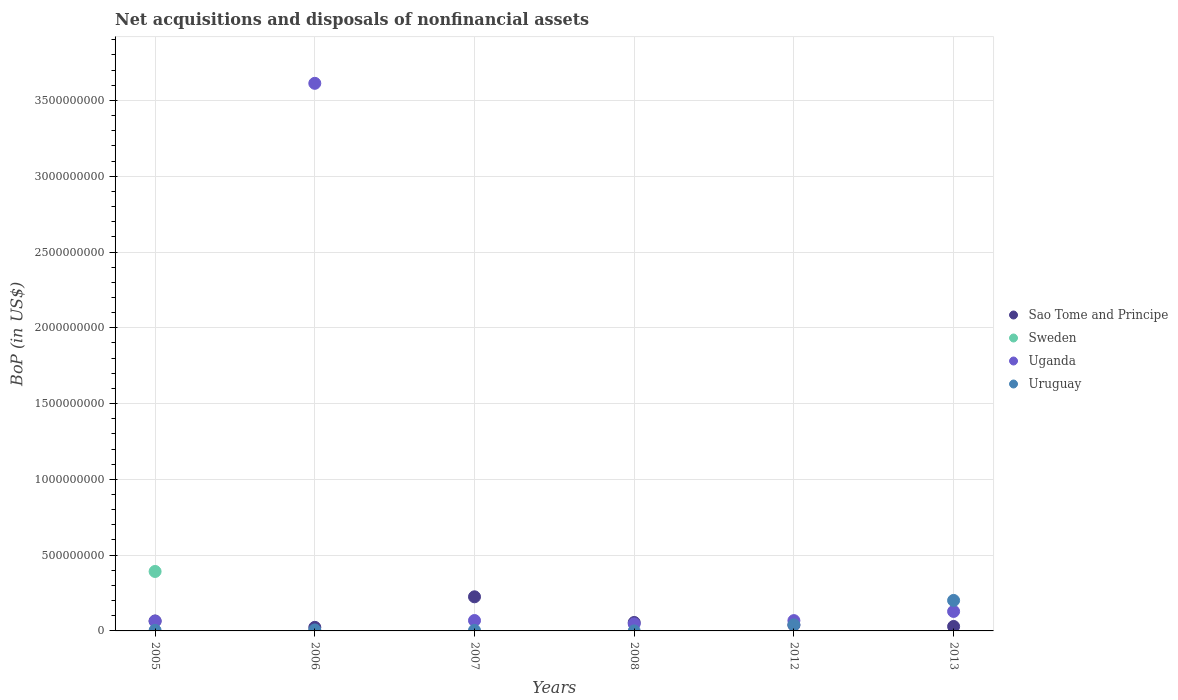How many different coloured dotlines are there?
Keep it short and to the point. 4. What is the Balance of Payments in Sao Tome and Principe in 2007?
Keep it short and to the point. 2.25e+08. Across all years, what is the maximum Balance of Payments in Sao Tome and Principe?
Your answer should be compact. 2.25e+08. Across all years, what is the minimum Balance of Payments in Uruguay?
Your response must be concise. 2.14e+05. What is the total Balance of Payments in Uruguay in the graph?
Give a very brief answer. 2.55e+08. What is the difference between the Balance of Payments in Uruguay in 2008 and that in 2013?
Keep it short and to the point. -2.01e+08. What is the difference between the Balance of Payments in Sao Tome and Principe in 2013 and the Balance of Payments in Uruguay in 2005?
Make the answer very short. 2.56e+07. What is the average Balance of Payments in Sao Tome and Principe per year?
Your response must be concise. 7.30e+07. In the year 2005, what is the difference between the Balance of Payments in Uruguay and Balance of Payments in Sweden?
Provide a succinct answer. -3.88e+08. What is the ratio of the Balance of Payments in Uruguay in 2008 to that in 2012?
Your answer should be compact. 0.01. Is the Balance of Payments in Uganda in 2006 less than that in 2012?
Your answer should be compact. No. What is the difference between the highest and the second highest Balance of Payments in Uruguay?
Ensure brevity in your answer.  1.61e+08. What is the difference between the highest and the lowest Balance of Payments in Sao Tome and Principe?
Your response must be concise. 2.02e+08. In how many years, is the Balance of Payments in Uruguay greater than the average Balance of Payments in Uruguay taken over all years?
Your response must be concise. 1. Is the sum of the Balance of Payments in Sao Tome and Principe in 2006 and 2012 greater than the maximum Balance of Payments in Uganda across all years?
Offer a terse response. No. Is it the case that in every year, the sum of the Balance of Payments in Uganda and Balance of Payments in Sao Tome and Principe  is greater than the Balance of Payments in Sweden?
Make the answer very short. No. Does the Balance of Payments in Uganda monotonically increase over the years?
Ensure brevity in your answer.  No. Is the Balance of Payments in Sweden strictly less than the Balance of Payments in Uganda over the years?
Offer a very short reply. No. What is the difference between two consecutive major ticks on the Y-axis?
Give a very brief answer. 5.00e+08. Does the graph contain grids?
Ensure brevity in your answer.  Yes. Where does the legend appear in the graph?
Give a very brief answer. Center right. How are the legend labels stacked?
Your response must be concise. Vertical. What is the title of the graph?
Your response must be concise. Net acquisitions and disposals of nonfinancial assets. What is the label or title of the Y-axis?
Keep it short and to the point. BoP (in US$). What is the BoP (in US$) in Sao Tome and Principe in 2005?
Provide a short and direct response. 6.56e+07. What is the BoP (in US$) in Sweden in 2005?
Ensure brevity in your answer.  3.92e+08. What is the BoP (in US$) in Uganda in 2005?
Offer a terse response. 6.43e+07. What is the BoP (in US$) of Uruguay in 2005?
Offer a terse response. 3.83e+06. What is the BoP (in US$) in Sao Tome and Principe in 2006?
Your answer should be compact. 2.35e+07. What is the BoP (in US$) in Uganda in 2006?
Provide a short and direct response. 3.61e+09. What is the BoP (in US$) of Uruguay in 2006?
Provide a short and direct response. 6.51e+06. What is the BoP (in US$) in Sao Tome and Principe in 2007?
Make the answer very short. 2.25e+08. What is the BoP (in US$) in Sweden in 2007?
Your answer should be compact. 0. What is the BoP (in US$) of Uganda in 2007?
Offer a terse response. 6.86e+07. What is the BoP (in US$) of Uruguay in 2007?
Ensure brevity in your answer.  3.71e+06. What is the BoP (in US$) of Sao Tome and Principe in 2008?
Your answer should be compact. 5.58e+07. What is the BoP (in US$) in Uganda in 2008?
Your answer should be compact. 4.65e+07. What is the BoP (in US$) in Uruguay in 2008?
Ensure brevity in your answer.  2.14e+05. What is the BoP (in US$) of Sao Tome and Principe in 2012?
Make the answer very short. 3.87e+07. What is the BoP (in US$) of Uganda in 2012?
Make the answer very short. 6.80e+07. What is the BoP (in US$) in Uruguay in 2012?
Ensure brevity in your answer.  4.00e+07. What is the BoP (in US$) of Sao Tome and Principe in 2013?
Your response must be concise. 2.94e+07. What is the BoP (in US$) in Uganda in 2013?
Offer a terse response. 1.29e+08. What is the BoP (in US$) in Uruguay in 2013?
Make the answer very short. 2.01e+08. Across all years, what is the maximum BoP (in US$) of Sao Tome and Principe?
Give a very brief answer. 2.25e+08. Across all years, what is the maximum BoP (in US$) in Sweden?
Your answer should be very brief. 3.92e+08. Across all years, what is the maximum BoP (in US$) of Uganda?
Your answer should be very brief. 3.61e+09. Across all years, what is the maximum BoP (in US$) of Uruguay?
Give a very brief answer. 2.01e+08. Across all years, what is the minimum BoP (in US$) in Sao Tome and Principe?
Your answer should be very brief. 2.35e+07. Across all years, what is the minimum BoP (in US$) of Uganda?
Your answer should be very brief. 4.65e+07. Across all years, what is the minimum BoP (in US$) in Uruguay?
Keep it short and to the point. 2.14e+05. What is the total BoP (in US$) of Sao Tome and Principe in the graph?
Provide a succinct answer. 4.38e+08. What is the total BoP (in US$) of Sweden in the graph?
Your response must be concise. 3.92e+08. What is the total BoP (in US$) in Uganda in the graph?
Your answer should be compact. 3.99e+09. What is the total BoP (in US$) in Uruguay in the graph?
Your response must be concise. 2.55e+08. What is the difference between the BoP (in US$) of Sao Tome and Principe in 2005 and that in 2006?
Offer a terse response. 4.21e+07. What is the difference between the BoP (in US$) of Uganda in 2005 and that in 2006?
Your answer should be compact. -3.55e+09. What is the difference between the BoP (in US$) of Uruguay in 2005 and that in 2006?
Keep it short and to the point. -2.67e+06. What is the difference between the BoP (in US$) in Sao Tome and Principe in 2005 and that in 2007?
Keep it short and to the point. -1.59e+08. What is the difference between the BoP (in US$) in Uganda in 2005 and that in 2007?
Offer a very short reply. -4.29e+06. What is the difference between the BoP (in US$) in Uruguay in 2005 and that in 2007?
Your answer should be compact. 1.25e+05. What is the difference between the BoP (in US$) in Sao Tome and Principe in 2005 and that in 2008?
Give a very brief answer. 9.87e+06. What is the difference between the BoP (in US$) of Uganda in 2005 and that in 2008?
Your answer should be compact. 1.78e+07. What is the difference between the BoP (in US$) in Uruguay in 2005 and that in 2008?
Offer a terse response. 3.62e+06. What is the difference between the BoP (in US$) in Sao Tome and Principe in 2005 and that in 2012?
Provide a succinct answer. 2.69e+07. What is the difference between the BoP (in US$) of Uganda in 2005 and that in 2012?
Provide a succinct answer. -3.70e+06. What is the difference between the BoP (in US$) of Uruguay in 2005 and that in 2012?
Offer a terse response. -3.62e+07. What is the difference between the BoP (in US$) of Sao Tome and Principe in 2005 and that in 2013?
Provide a short and direct response. 3.62e+07. What is the difference between the BoP (in US$) of Uganda in 2005 and that in 2013?
Keep it short and to the point. -6.43e+07. What is the difference between the BoP (in US$) in Uruguay in 2005 and that in 2013?
Make the answer very short. -1.97e+08. What is the difference between the BoP (in US$) of Sao Tome and Principe in 2006 and that in 2007?
Ensure brevity in your answer.  -2.02e+08. What is the difference between the BoP (in US$) of Uganda in 2006 and that in 2007?
Ensure brevity in your answer.  3.54e+09. What is the difference between the BoP (in US$) of Uruguay in 2006 and that in 2007?
Ensure brevity in your answer.  2.80e+06. What is the difference between the BoP (in US$) in Sao Tome and Principe in 2006 and that in 2008?
Keep it short and to the point. -3.22e+07. What is the difference between the BoP (in US$) in Uganda in 2006 and that in 2008?
Your answer should be compact. 3.57e+09. What is the difference between the BoP (in US$) in Uruguay in 2006 and that in 2008?
Offer a very short reply. 6.29e+06. What is the difference between the BoP (in US$) of Sao Tome and Principe in 2006 and that in 2012?
Offer a terse response. -1.52e+07. What is the difference between the BoP (in US$) of Uganda in 2006 and that in 2012?
Your answer should be very brief. 3.54e+09. What is the difference between the BoP (in US$) in Uruguay in 2006 and that in 2012?
Make the answer very short. -3.35e+07. What is the difference between the BoP (in US$) of Sao Tome and Principe in 2006 and that in 2013?
Offer a very short reply. -5.87e+06. What is the difference between the BoP (in US$) of Uganda in 2006 and that in 2013?
Offer a terse response. 3.48e+09. What is the difference between the BoP (in US$) of Uruguay in 2006 and that in 2013?
Your answer should be compact. -1.95e+08. What is the difference between the BoP (in US$) of Sao Tome and Principe in 2007 and that in 2008?
Offer a terse response. 1.69e+08. What is the difference between the BoP (in US$) of Uganda in 2007 and that in 2008?
Provide a succinct answer. 2.21e+07. What is the difference between the BoP (in US$) in Uruguay in 2007 and that in 2008?
Give a very brief answer. 3.49e+06. What is the difference between the BoP (in US$) of Sao Tome and Principe in 2007 and that in 2012?
Offer a terse response. 1.86e+08. What is the difference between the BoP (in US$) in Uganda in 2007 and that in 2012?
Give a very brief answer. 5.95e+05. What is the difference between the BoP (in US$) of Uruguay in 2007 and that in 2012?
Offer a terse response. -3.63e+07. What is the difference between the BoP (in US$) in Sao Tome and Principe in 2007 and that in 2013?
Provide a short and direct response. 1.96e+08. What is the difference between the BoP (in US$) in Uganda in 2007 and that in 2013?
Provide a succinct answer. -6.00e+07. What is the difference between the BoP (in US$) of Uruguay in 2007 and that in 2013?
Offer a very short reply. -1.97e+08. What is the difference between the BoP (in US$) in Sao Tome and Principe in 2008 and that in 2012?
Provide a short and direct response. 1.71e+07. What is the difference between the BoP (in US$) of Uganda in 2008 and that in 2012?
Offer a terse response. -2.15e+07. What is the difference between the BoP (in US$) in Uruguay in 2008 and that in 2012?
Offer a terse response. -3.98e+07. What is the difference between the BoP (in US$) of Sao Tome and Principe in 2008 and that in 2013?
Offer a very short reply. 2.64e+07. What is the difference between the BoP (in US$) in Uganda in 2008 and that in 2013?
Your answer should be very brief. -8.21e+07. What is the difference between the BoP (in US$) in Uruguay in 2008 and that in 2013?
Provide a short and direct response. -2.01e+08. What is the difference between the BoP (in US$) in Sao Tome and Principe in 2012 and that in 2013?
Make the answer very short. 9.30e+06. What is the difference between the BoP (in US$) of Uganda in 2012 and that in 2013?
Your answer should be compact. -6.06e+07. What is the difference between the BoP (in US$) of Uruguay in 2012 and that in 2013?
Your answer should be very brief. -1.61e+08. What is the difference between the BoP (in US$) in Sao Tome and Principe in 2005 and the BoP (in US$) in Uganda in 2006?
Provide a short and direct response. -3.55e+09. What is the difference between the BoP (in US$) of Sao Tome and Principe in 2005 and the BoP (in US$) of Uruguay in 2006?
Provide a succinct answer. 5.91e+07. What is the difference between the BoP (in US$) in Sweden in 2005 and the BoP (in US$) in Uganda in 2006?
Offer a terse response. -3.22e+09. What is the difference between the BoP (in US$) in Sweden in 2005 and the BoP (in US$) in Uruguay in 2006?
Ensure brevity in your answer.  3.86e+08. What is the difference between the BoP (in US$) in Uganda in 2005 and the BoP (in US$) in Uruguay in 2006?
Make the answer very short. 5.78e+07. What is the difference between the BoP (in US$) in Sao Tome and Principe in 2005 and the BoP (in US$) in Uganda in 2007?
Your response must be concise. -2.96e+06. What is the difference between the BoP (in US$) in Sao Tome and Principe in 2005 and the BoP (in US$) in Uruguay in 2007?
Offer a very short reply. 6.19e+07. What is the difference between the BoP (in US$) of Sweden in 2005 and the BoP (in US$) of Uganda in 2007?
Keep it short and to the point. 3.24e+08. What is the difference between the BoP (in US$) of Sweden in 2005 and the BoP (in US$) of Uruguay in 2007?
Make the answer very short. 3.89e+08. What is the difference between the BoP (in US$) of Uganda in 2005 and the BoP (in US$) of Uruguay in 2007?
Provide a short and direct response. 6.06e+07. What is the difference between the BoP (in US$) in Sao Tome and Principe in 2005 and the BoP (in US$) in Uganda in 2008?
Offer a terse response. 1.91e+07. What is the difference between the BoP (in US$) of Sao Tome and Principe in 2005 and the BoP (in US$) of Uruguay in 2008?
Provide a succinct answer. 6.54e+07. What is the difference between the BoP (in US$) of Sweden in 2005 and the BoP (in US$) of Uganda in 2008?
Provide a succinct answer. 3.46e+08. What is the difference between the BoP (in US$) of Sweden in 2005 and the BoP (in US$) of Uruguay in 2008?
Offer a very short reply. 3.92e+08. What is the difference between the BoP (in US$) in Uganda in 2005 and the BoP (in US$) in Uruguay in 2008?
Make the answer very short. 6.41e+07. What is the difference between the BoP (in US$) in Sao Tome and Principe in 2005 and the BoP (in US$) in Uganda in 2012?
Give a very brief answer. -2.37e+06. What is the difference between the BoP (in US$) in Sao Tome and Principe in 2005 and the BoP (in US$) in Uruguay in 2012?
Make the answer very short. 2.56e+07. What is the difference between the BoP (in US$) in Sweden in 2005 and the BoP (in US$) in Uganda in 2012?
Provide a succinct answer. 3.24e+08. What is the difference between the BoP (in US$) of Sweden in 2005 and the BoP (in US$) of Uruguay in 2012?
Your answer should be very brief. 3.52e+08. What is the difference between the BoP (in US$) of Uganda in 2005 and the BoP (in US$) of Uruguay in 2012?
Make the answer very short. 2.43e+07. What is the difference between the BoP (in US$) in Sao Tome and Principe in 2005 and the BoP (in US$) in Uganda in 2013?
Provide a succinct answer. -6.30e+07. What is the difference between the BoP (in US$) of Sao Tome and Principe in 2005 and the BoP (in US$) of Uruguay in 2013?
Provide a succinct answer. -1.36e+08. What is the difference between the BoP (in US$) of Sweden in 2005 and the BoP (in US$) of Uganda in 2013?
Give a very brief answer. 2.64e+08. What is the difference between the BoP (in US$) of Sweden in 2005 and the BoP (in US$) of Uruguay in 2013?
Offer a terse response. 1.91e+08. What is the difference between the BoP (in US$) of Uganda in 2005 and the BoP (in US$) of Uruguay in 2013?
Offer a terse response. -1.37e+08. What is the difference between the BoP (in US$) in Sao Tome and Principe in 2006 and the BoP (in US$) in Uganda in 2007?
Provide a succinct answer. -4.51e+07. What is the difference between the BoP (in US$) in Sao Tome and Principe in 2006 and the BoP (in US$) in Uruguay in 2007?
Provide a short and direct response. 1.98e+07. What is the difference between the BoP (in US$) in Uganda in 2006 and the BoP (in US$) in Uruguay in 2007?
Offer a very short reply. 3.61e+09. What is the difference between the BoP (in US$) of Sao Tome and Principe in 2006 and the BoP (in US$) of Uganda in 2008?
Your answer should be compact. -2.30e+07. What is the difference between the BoP (in US$) of Sao Tome and Principe in 2006 and the BoP (in US$) of Uruguay in 2008?
Your response must be concise. 2.33e+07. What is the difference between the BoP (in US$) of Uganda in 2006 and the BoP (in US$) of Uruguay in 2008?
Offer a very short reply. 3.61e+09. What is the difference between the BoP (in US$) of Sao Tome and Principe in 2006 and the BoP (in US$) of Uganda in 2012?
Ensure brevity in your answer.  -4.45e+07. What is the difference between the BoP (in US$) of Sao Tome and Principe in 2006 and the BoP (in US$) of Uruguay in 2012?
Provide a succinct answer. -1.65e+07. What is the difference between the BoP (in US$) of Uganda in 2006 and the BoP (in US$) of Uruguay in 2012?
Your response must be concise. 3.57e+09. What is the difference between the BoP (in US$) in Sao Tome and Principe in 2006 and the BoP (in US$) in Uganda in 2013?
Provide a succinct answer. -1.05e+08. What is the difference between the BoP (in US$) of Sao Tome and Principe in 2006 and the BoP (in US$) of Uruguay in 2013?
Provide a succinct answer. -1.78e+08. What is the difference between the BoP (in US$) in Uganda in 2006 and the BoP (in US$) in Uruguay in 2013?
Your answer should be very brief. 3.41e+09. What is the difference between the BoP (in US$) of Sao Tome and Principe in 2007 and the BoP (in US$) of Uganda in 2008?
Provide a short and direct response. 1.79e+08. What is the difference between the BoP (in US$) in Sao Tome and Principe in 2007 and the BoP (in US$) in Uruguay in 2008?
Your answer should be compact. 2.25e+08. What is the difference between the BoP (in US$) in Uganda in 2007 and the BoP (in US$) in Uruguay in 2008?
Provide a short and direct response. 6.84e+07. What is the difference between the BoP (in US$) in Sao Tome and Principe in 2007 and the BoP (in US$) in Uganda in 2012?
Provide a succinct answer. 1.57e+08. What is the difference between the BoP (in US$) of Sao Tome and Principe in 2007 and the BoP (in US$) of Uruguay in 2012?
Ensure brevity in your answer.  1.85e+08. What is the difference between the BoP (in US$) of Uganda in 2007 and the BoP (in US$) of Uruguay in 2012?
Your answer should be very brief. 2.86e+07. What is the difference between the BoP (in US$) in Sao Tome and Principe in 2007 and the BoP (in US$) in Uganda in 2013?
Offer a very short reply. 9.65e+07. What is the difference between the BoP (in US$) of Sao Tome and Principe in 2007 and the BoP (in US$) of Uruguay in 2013?
Provide a succinct answer. 2.40e+07. What is the difference between the BoP (in US$) of Uganda in 2007 and the BoP (in US$) of Uruguay in 2013?
Your answer should be very brief. -1.33e+08. What is the difference between the BoP (in US$) of Sao Tome and Principe in 2008 and the BoP (in US$) of Uganda in 2012?
Provide a succinct answer. -1.22e+07. What is the difference between the BoP (in US$) in Sao Tome and Principe in 2008 and the BoP (in US$) in Uruguay in 2012?
Ensure brevity in your answer.  1.58e+07. What is the difference between the BoP (in US$) in Uganda in 2008 and the BoP (in US$) in Uruguay in 2012?
Your answer should be very brief. 6.50e+06. What is the difference between the BoP (in US$) of Sao Tome and Principe in 2008 and the BoP (in US$) of Uganda in 2013?
Your answer should be very brief. -7.28e+07. What is the difference between the BoP (in US$) of Sao Tome and Principe in 2008 and the BoP (in US$) of Uruguay in 2013?
Ensure brevity in your answer.  -1.45e+08. What is the difference between the BoP (in US$) of Uganda in 2008 and the BoP (in US$) of Uruguay in 2013?
Provide a succinct answer. -1.55e+08. What is the difference between the BoP (in US$) in Sao Tome and Principe in 2012 and the BoP (in US$) in Uganda in 2013?
Your answer should be compact. -8.99e+07. What is the difference between the BoP (in US$) in Sao Tome and Principe in 2012 and the BoP (in US$) in Uruguay in 2013?
Keep it short and to the point. -1.62e+08. What is the difference between the BoP (in US$) in Uganda in 2012 and the BoP (in US$) in Uruguay in 2013?
Provide a succinct answer. -1.33e+08. What is the average BoP (in US$) in Sao Tome and Principe per year?
Make the answer very short. 7.30e+07. What is the average BoP (in US$) of Sweden per year?
Keep it short and to the point. 6.54e+07. What is the average BoP (in US$) in Uganda per year?
Your answer should be compact. 6.65e+08. What is the average BoP (in US$) in Uruguay per year?
Make the answer very short. 4.26e+07. In the year 2005, what is the difference between the BoP (in US$) of Sao Tome and Principe and BoP (in US$) of Sweden?
Keep it short and to the point. -3.27e+08. In the year 2005, what is the difference between the BoP (in US$) in Sao Tome and Principe and BoP (in US$) in Uganda?
Make the answer very short. 1.33e+06. In the year 2005, what is the difference between the BoP (in US$) of Sao Tome and Principe and BoP (in US$) of Uruguay?
Provide a short and direct response. 6.18e+07. In the year 2005, what is the difference between the BoP (in US$) in Sweden and BoP (in US$) in Uganda?
Offer a very short reply. 3.28e+08. In the year 2005, what is the difference between the BoP (in US$) of Sweden and BoP (in US$) of Uruguay?
Your response must be concise. 3.88e+08. In the year 2005, what is the difference between the BoP (in US$) in Uganda and BoP (in US$) in Uruguay?
Provide a short and direct response. 6.05e+07. In the year 2006, what is the difference between the BoP (in US$) in Sao Tome and Principe and BoP (in US$) in Uganda?
Ensure brevity in your answer.  -3.59e+09. In the year 2006, what is the difference between the BoP (in US$) in Sao Tome and Principe and BoP (in US$) in Uruguay?
Give a very brief answer. 1.70e+07. In the year 2006, what is the difference between the BoP (in US$) of Uganda and BoP (in US$) of Uruguay?
Keep it short and to the point. 3.61e+09. In the year 2007, what is the difference between the BoP (in US$) of Sao Tome and Principe and BoP (in US$) of Uganda?
Your answer should be compact. 1.57e+08. In the year 2007, what is the difference between the BoP (in US$) in Sao Tome and Principe and BoP (in US$) in Uruguay?
Offer a very short reply. 2.21e+08. In the year 2007, what is the difference between the BoP (in US$) in Uganda and BoP (in US$) in Uruguay?
Make the answer very short. 6.49e+07. In the year 2008, what is the difference between the BoP (in US$) in Sao Tome and Principe and BoP (in US$) in Uganda?
Offer a terse response. 9.27e+06. In the year 2008, what is the difference between the BoP (in US$) in Sao Tome and Principe and BoP (in US$) in Uruguay?
Provide a succinct answer. 5.56e+07. In the year 2008, what is the difference between the BoP (in US$) of Uganda and BoP (in US$) of Uruguay?
Offer a terse response. 4.63e+07. In the year 2012, what is the difference between the BoP (in US$) of Sao Tome and Principe and BoP (in US$) of Uganda?
Your response must be concise. -2.93e+07. In the year 2012, what is the difference between the BoP (in US$) in Sao Tome and Principe and BoP (in US$) in Uruguay?
Make the answer very short. -1.28e+06. In the year 2012, what is the difference between the BoP (in US$) of Uganda and BoP (in US$) of Uruguay?
Ensure brevity in your answer.  2.80e+07. In the year 2013, what is the difference between the BoP (in US$) of Sao Tome and Principe and BoP (in US$) of Uganda?
Offer a terse response. -9.92e+07. In the year 2013, what is the difference between the BoP (in US$) of Sao Tome and Principe and BoP (in US$) of Uruguay?
Provide a succinct answer. -1.72e+08. In the year 2013, what is the difference between the BoP (in US$) of Uganda and BoP (in US$) of Uruguay?
Give a very brief answer. -7.25e+07. What is the ratio of the BoP (in US$) in Sao Tome and Principe in 2005 to that in 2006?
Ensure brevity in your answer.  2.79. What is the ratio of the BoP (in US$) of Uganda in 2005 to that in 2006?
Provide a succinct answer. 0.02. What is the ratio of the BoP (in US$) of Uruguay in 2005 to that in 2006?
Keep it short and to the point. 0.59. What is the ratio of the BoP (in US$) of Sao Tome and Principe in 2005 to that in 2007?
Your answer should be very brief. 0.29. What is the ratio of the BoP (in US$) in Uganda in 2005 to that in 2007?
Ensure brevity in your answer.  0.94. What is the ratio of the BoP (in US$) of Uruguay in 2005 to that in 2007?
Ensure brevity in your answer.  1.03. What is the ratio of the BoP (in US$) in Sao Tome and Principe in 2005 to that in 2008?
Keep it short and to the point. 1.18. What is the ratio of the BoP (in US$) in Uganda in 2005 to that in 2008?
Your response must be concise. 1.38. What is the ratio of the BoP (in US$) of Uruguay in 2005 to that in 2008?
Your answer should be compact. 17.91. What is the ratio of the BoP (in US$) of Sao Tome and Principe in 2005 to that in 2012?
Provide a short and direct response. 1.7. What is the ratio of the BoP (in US$) in Uganda in 2005 to that in 2012?
Your answer should be compact. 0.95. What is the ratio of the BoP (in US$) in Uruguay in 2005 to that in 2012?
Your response must be concise. 0.1. What is the ratio of the BoP (in US$) of Sao Tome and Principe in 2005 to that in 2013?
Provide a short and direct response. 2.23. What is the ratio of the BoP (in US$) in Uruguay in 2005 to that in 2013?
Offer a terse response. 0.02. What is the ratio of the BoP (in US$) in Sao Tome and Principe in 2006 to that in 2007?
Your response must be concise. 0.1. What is the ratio of the BoP (in US$) in Uganda in 2006 to that in 2007?
Make the answer very short. 52.66. What is the ratio of the BoP (in US$) in Uruguay in 2006 to that in 2007?
Offer a very short reply. 1.75. What is the ratio of the BoP (in US$) of Sao Tome and Principe in 2006 to that in 2008?
Offer a terse response. 0.42. What is the ratio of the BoP (in US$) of Uganda in 2006 to that in 2008?
Provide a succinct answer. 77.69. What is the ratio of the BoP (in US$) in Uruguay in 2006 to that in 2008?
Give a very brief answer. 30.4. What is the ratio of the BoP (in US$) in Sao Tome and Principe in 2006 to that in 2012?
Provide a short and direct response. 0.61. What is the ratio of the BoP (in US$) of Uganda in 2006 to that in 2012?
Offer a terse response. 53.12. What is the ratio of the BoP (in US$) of Uruguay in 2006 to that in 2012?
Give a very brief answer. 0.16. What is the ratio of the BoP (in US$) in Sao Tome and Principe in 2006 to that in 2013?
Offer a very short reply. 0.8. What is the ratio of the BoP (in US$) of Uganda in 2006 to that in 2013?
Offer a terse response. 28.09. What is the ratio of the BoP (in US$) of Uruguay in 2006 to that in 2013?
Keep it short and to the point. 0.03. What is the ratio of the BoP (in US$) of Sao Tome and Principe in 2007 to that in 2008?
Offer a terse response. 4.04. What is the ratio of the BoP (in US$) of Uganda in 2007 to that in 2008?
Your answer should be very brief. 1.48. What is the ratio of the BoP (in US$) of Uruguay in 2007 to that in 2008?
Offer a terse response. 17.33. What is the ratio of the BoP (in US$) of Sao Tome and Principe in 2007 to that in 2012?
Give a very brief answer. 5.81. What is the ratio of the BoP (in US$) of Uganda in 2007 to that in 2012?
Offer a very short reply. 1.01. What is the ratio of the BoP (in US$) of Uruguay in 2007 to that in 2012?
Give a very brief answer. 0.09. What is the ratio of the BoP (in US$) of Sao Tome and Principe in 2007 to that in 2013?
Provide a succinct answer. 7.65. What is the ratio of the BoP (in US$) in Uganda in 2007 to that in 2013?
Your answer should be compact. 0.53. What is the ratio of the BoP (in US$) of Uruguay in 2007 to that in 2013?
Provide a short and direct response. 0.02. What is the ratio of the BoP (in US$) of Sao Tome and Principe in 2008 to that in 2012?
Your answer should be very brief. 1.44. What is the ratio of the BoP (in US$) of Uganda in 2008 to that in 2012?
Ensure brevity in your answer.  0.68. What is the ratio of the BoP (in US$) of Uruguay in 2008 to that in 2012?
Offer a very short reply. 0.01. What is the ratio of the BoP (in US$) of Sao Tome and Principe in 2008 to that in 2013?
Offer a terse response. 1.9. What is the ratio of the BoP (in US$) in Uganda in 2008 to that in 2013?
Ensure brevity in your answer.  0.36. What is the ratio of the BoP (in US$) in Uruguay in 2008 to that in 2013?
Offer a very short reply. 0. What is the ratio of the BoP (in US$) of Sao Tome and Principe in 2012 to that in 2013?
Ensure brevity in your answer.  1.32. What is the ratio of the BoP (in US$) in Uganda in 2012 to that in 2013?
Your response must be concise. 0.53. What is the ratio of the BoP (in US$) in Uruguay in 2012 to that in 2013?
Give a very brief answer. 0.2. What is the difference between the highest and the second highest BoP (in US$) of Sao Tome and Principe?
Give a very brief answer. 1.59e+08. What is the difference between the highest and the second highest BoP (in US$) in Uganda?
Offer a very short reply. 3.48e+09. What is the difference between the highest and the second highest BoP (in US$) of Uruguay?
Your answer should be very brief. 1.61e+08. What is the difference between the highest and the lowest BoP (in US$) in Sao Tome and Principe?
Your answer should be very brief. 2.02e+08. What is the difference between the highest and the lowest BoP (in US$) of Sweden?
Offer a very short reply. 3.92e+08. What is the difference between the highest and the lowest BoP (in US$) of Uganda?
Your answer should be compact. 3.57e+09. What is the difference between the highest and the lowest BoP (in US$) in Uruguay?
Keep it short and to the point. 2.01e+08. 